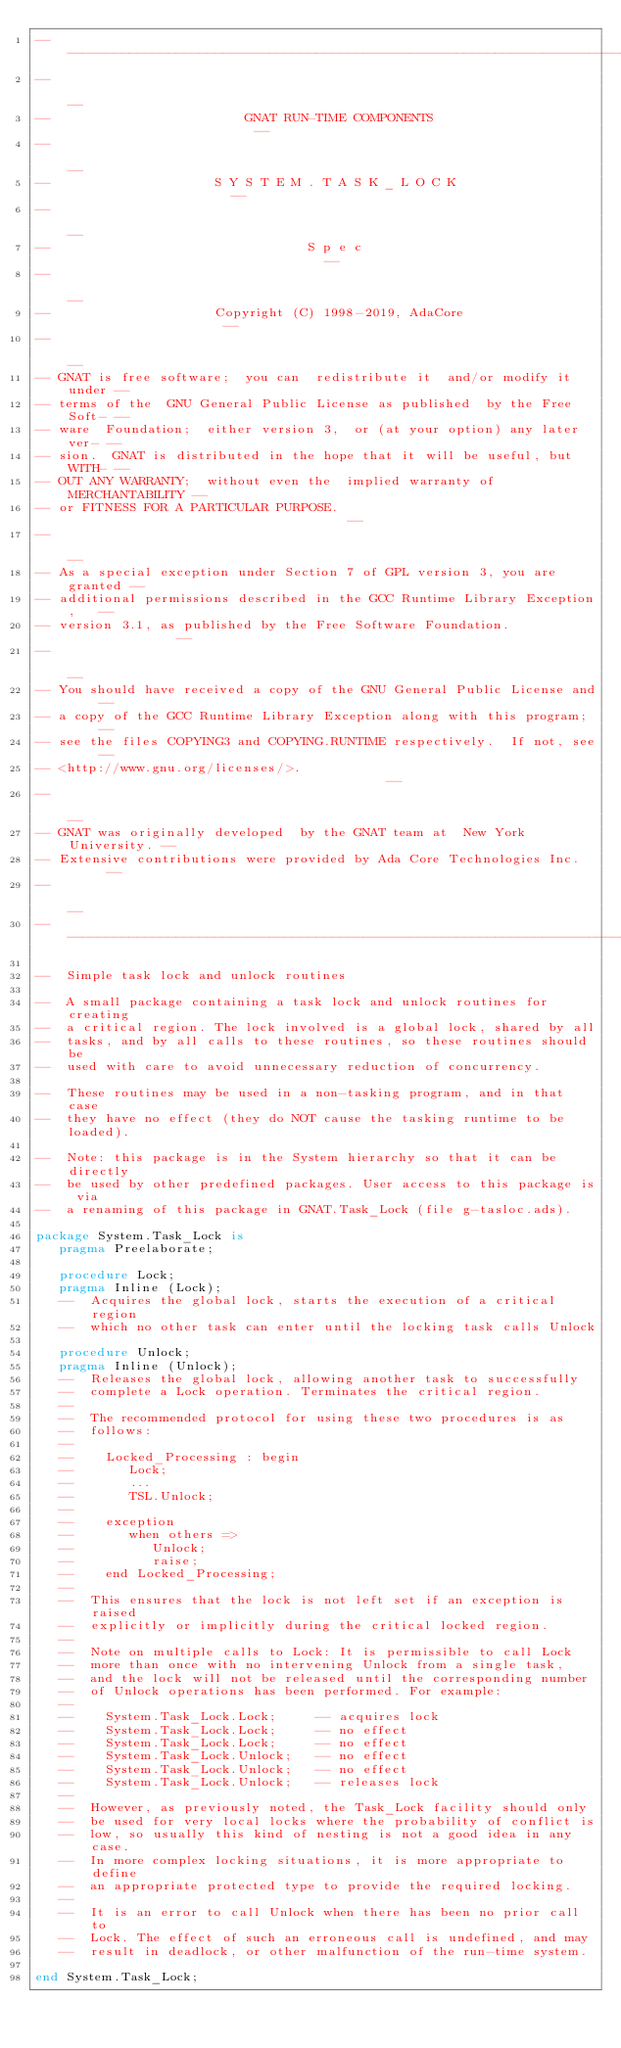Convert code to text. <code><loc_0><loc_0><loc_500><loc_500><_Ada_>------------------------------------------------------------------------------
--                                                                          --
--                         GNAT RUN-TIME COMPONENTS                         --
--                                                                          --
--                     S Y S T E M . T A S K _ L O C K                      --
--                                                                          --
--                                 S p e c                                  --
--                                                                          --
--                     Copyright (C) 1998-2019, AdaCore                     --
--                                                                          --
-- GNAT is free software;  you can  redistribute it  and/or modify it under --
-- terms of the  GNU General Public License as published  by the Free Soft- --
-- ware  Foundation;  either version 3,  or (at your option) any later ver- --
-- sion.  GNAT is distributed in the hope that it will be useful, but WITH- --
-- OUT ANY WARRANTY;  without even the  implied warranty of MERCHANTABILITY --
-- or FITNESS FOR A PARTICULAR PURPOSE.                                     --
--                                                                          --
-- As a special exception under Section 7 of GPL version 3, you are granted --
-- additional permissions described in the GCC Runtime Library Exception,   --
-- version 3.1, as published by the Free Software Foundation.               --
--                                                                          --
-- You should have received a copy of the GNU General Public License and    --
-- a copy of the GCC Runtime Library Exception along with this program;     --
-- see the files COPYING3 and COPYING.RUNTIME respectively.  If not, see    --
-- <http://www.gnu.org/licenses/>.                                          --
--                                                                          --
-- GNAT was originally developed  by the GNAT team at  New York University. --
-- Extensive contributions were provided by Ada Core Technologies Inc.      --
--                                                                          --
------------------------------------------------------------------------------

--  Simple task lock and unlock routines

--  A small package containing a task lock and unlock routines for creating
--  a critical region. The lock involved is a global lock, shared by all
--  tasks, and by all calls to these routines, so these routines should be
--  used with care to avoid unnecessary reduction of concurrency.

--  These routines may be used in a non-tasking program, and in that case
--  they have no effect (they do NOT cause the tasking runtime to be loaded).

--  Note: this package is in the System hierarchy so that it can be directly
--  be used by other predefined packages. User access to this package is via
--  a renaming of this package in GNAT.Task_Lock (file g-tasloc.ads).

package System.Task_Lock is
   pragma Preelaborate;

   procedure Lock;
   pragma Inline (Lock);
   --  Acquires the global lock, starts the execution of a critical region
   --  which no other task can enter until the locking task calls Unlock

   procedure Unlock;
   pragma Inline (Unlock);
   --  Releases the global lock, allowing another task to successfully
   --  complete a Lock operation. Terminates the critical region.
   --
   --  The recommended protocol for using these two procedures is as
   --  follows:
   --
   --    Locked_Processing : begin
   --       Lock;
   --       ...
   --       TSL.Unlock;
   --
   --    exception
   --       when others =>
   --          Unlock;
   --          raise;
   --    end Locked_Processing;
   --
   --  This ensures that the lock is not left set if an exception is raised
   --  explicitly or implicitly during the critical locked region.
   --
   --  Note on multiple calls to Lock: It is permissible to call Lock
   --  more than once with no intervening Unlock from a single task,
   --  and the lock will not be released until the corresponding number
   --  of Unlock operations has been performed. For example:
   --
   --    System.Task_Lock.Lock;     -- acquires lock
   --    System.Task_Lock.Lock;     -- no effect
   --    System.Task_Lock.Lock;     -- no effect
   --    System.Task_Lock.Unlock;   -- no effect
   --    System.Task_Lock.Unlock;   -- no effect
   --    System.Task_Lock.Unlock;   -- releases lock
   --
   --  However, as previously noted, the Task_Lock facility should only
   --  be used for very local locks where the probability of conflict is
   --  low, so usually this kind of nesting is not a good idea in any case.
   --  In more complex locking situations, it is more appropriate to define
   --  an appropriate protected type to provide the required locking.
   --
   --  It is an error to call Unlock when there has been no prior call to
   --  Lock. The effect of such an erroneous call is undefined, and may
   --  result in deadlock, or other malfunction of the run-time system.

end System.Task_Lock;
</code> 